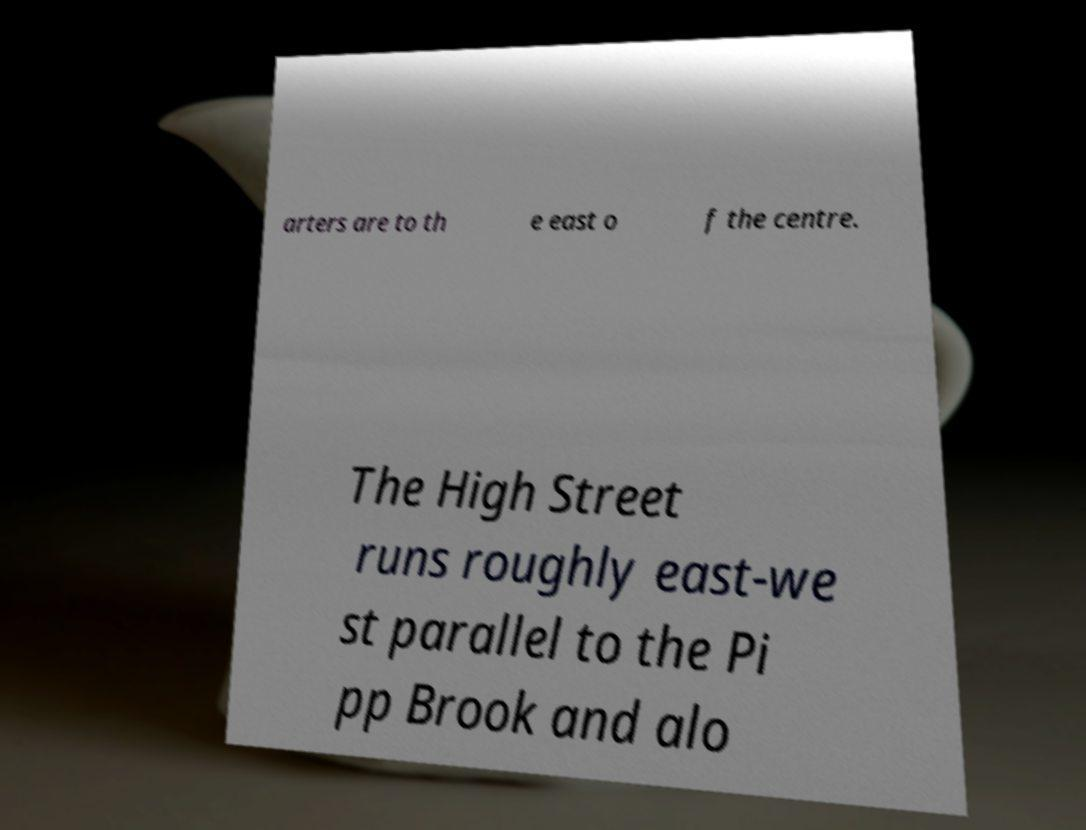Could you assist in decoding the text presented in this image and type it out clearly? arters are to th e east o f the centre. The High Street runs roughly east-we st parallel to the Pi pp Brook and alo 